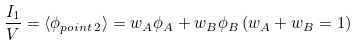<formula> <loc_0><loc_0><loc_500><loc_500>\frac { I _ { 1 } } { V } = \langle \phi _ { p o i n t \, 2 } \rangle = w _ { A } \phi _ { A } + w _ { B } \phi _ { B } \, ( w _ { A } + w _ { B } = 1 )</formula> 